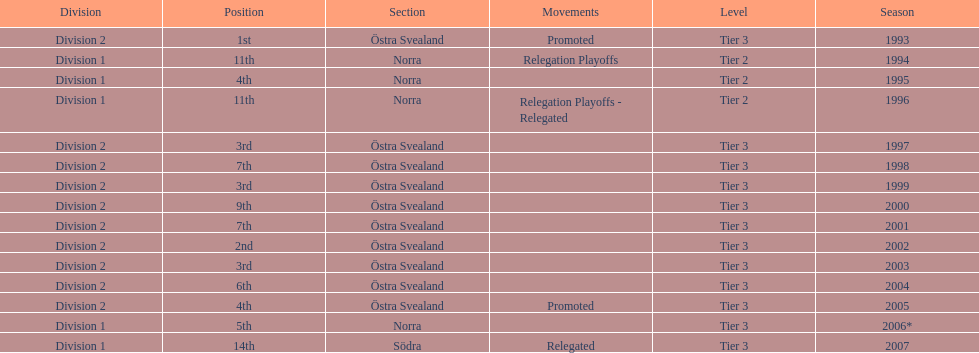What year is at least on the list? 2007. 